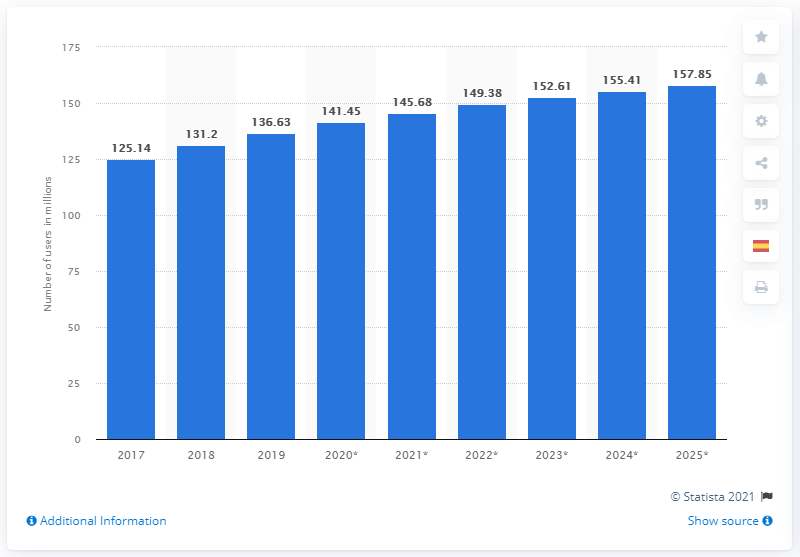List a handful of essential elements in this visual. In 2019, there were approximately 136.63 million social media users in Brazil. By 2025, it is projected that over 157.85 million Brazilians will use social media. 